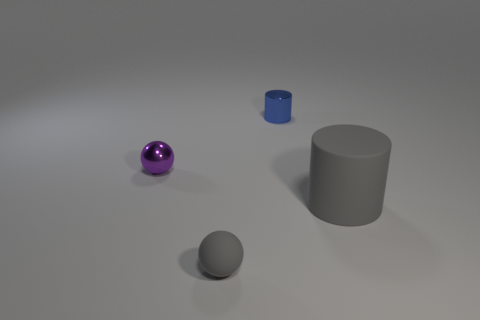Add 4 small cylinders. How many objects exist? 8 Subtract 0 red cylinders. How many objects are left? 4 Subtract all purple metallic spheres. Subtract all blue things. How many objects are left? 2 Add 2 tiny gray rubber balls. How many tiny gray rubber balls are left? 3 Add 1 cyan things. How many cyan things exist? 1 